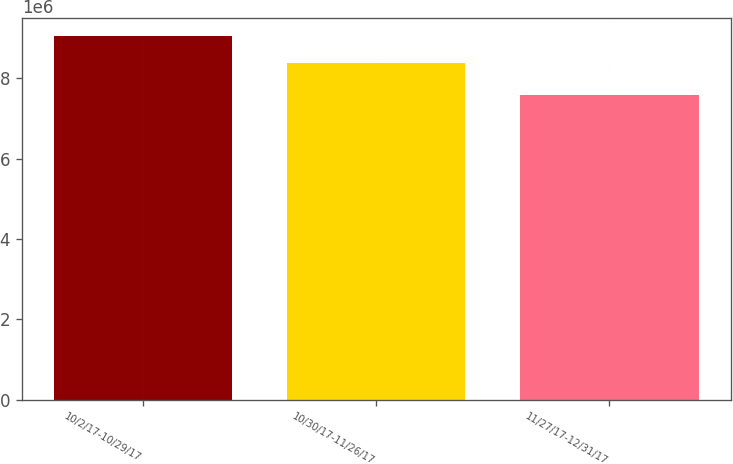Convert chart to OTSL. <chart><loc_0><loc_0><loc_500><loc_500><bar_chart><fcel>10/2/17-10/29/17<fcel>10/30/17-11/26/17<fcel>11/27/17-12/31/17<nl><fcel>9.0587e+06<fcel>8.38886e+06<fcel>7.58541e+06<nl></chart> 